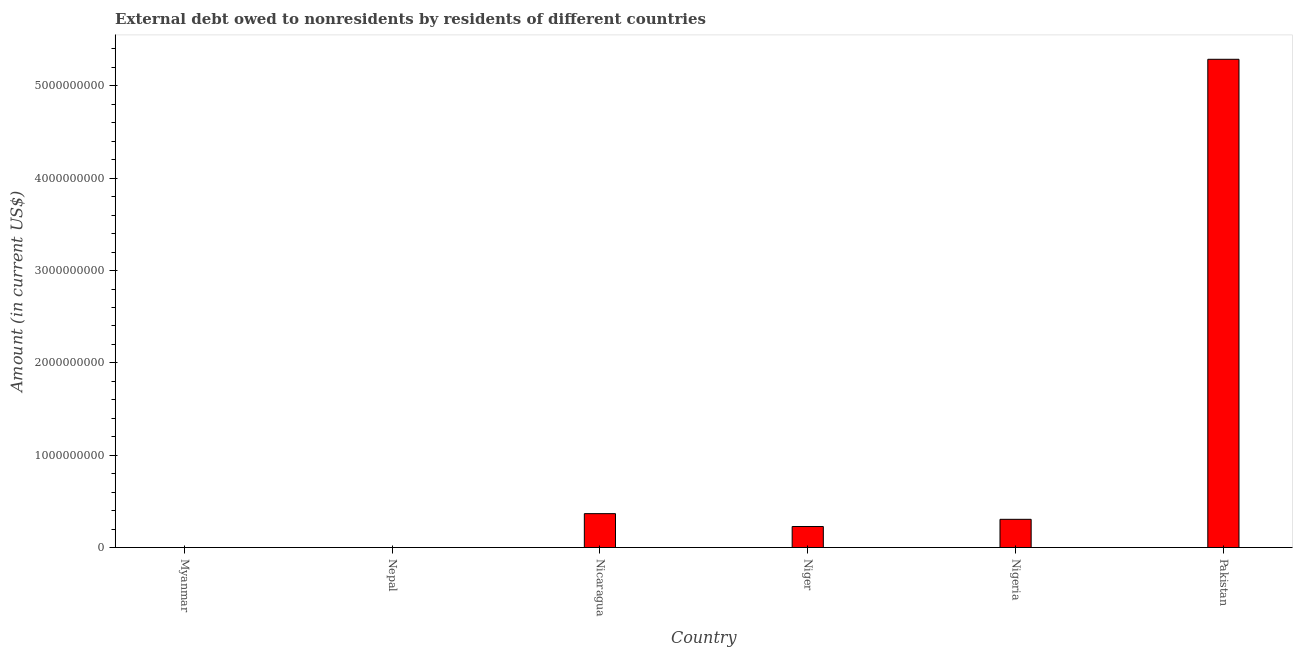Does the graph contain any zero values?
Keep it short and to the point. Yes. Does the graph contain grids?
Ensure brevity in your answer.  No. What is the title of the graph?
Your response must be concise. External debt owed to nonresidents by residents of different countries. What is the label or title of the Y-axis?
Your response must be concise. Amount (in current US$). What is the debt in Nicaragua?
Offer a terse response. 3.67e+08. Across all countries, what is the maximum debt?
Provide a short and direct response. 5.29e+09. In which country was the debt maximum?
Your response must be concise. Pakistan. What is the sum of the debt?
Provide a succinct answer. 6.19e+09. What is the difference between the debt in Niger and Pakistan?
Offer a terse response. -5.06e+09. What is the average debt per country?
Provide a succinct answer. 1.03e+09. What is the median debt?
Offer a very short reply. 2.66e+08. What is the ratio of the debt in Niger to that in Nigeria?
Provide a short and direct response. 0.74. Is the difference between the debt in Nigeria and Pakistan greater than the difference between any two countries?
Your response must be concise. No. What is the difference between the highest and the second highest debt?
Ensure brevity in your answer.  4.92e+09. What is the difference between the highest and the lowest debt?
Your answer should be very brief. 5.29e+09. What is the difference between two consecutive major ticks on the Y-axis?
Your answer should be very brief. 1.00e+09. Are the values on the major ticks of Y-axis written in scientific E-notation?
Offer a terse response. No. What is the Amount (in current US$) in Nepal?
Your answer should be compact. 0. What is the Amount (in current US$) in Nicaragua?
Your response must be concise. 3.67e+08. What is the Amount (in current US$) of Niger?
Make the answer very short. 2.27e+08. What is the Amount (in current US$) in Nigeria?
Make the answer very short. 3.05e+08. What is the Amount (in current US$) of Pakistan?
Your answer should be very brief. 5.29e+09. What is the difference between the Amount (in current US$) in Nicaragua and Niger?
Keep it short and to the point. 1.39e+08. What is the difference between the Amount (in current US$) in Nicaragua and Nigeria?
Keep it short and to the point. 6.15e+07. What is the difference between the Amount (in current US$) in Nicaragua and Pakistan?
Your answer should be very brief. -4.92e+09. What is the difference between the Amount (in current US$) in Niger and Nigeria?
Make the answer very short. -7.80e+07. What is the difference between the Amount (in current US$) in Niger and Pakistan?
Offer a terse response. -5.06e+09. What is the difference between the Amount (in current US$) in Nigeria and Pakistan?
Ensure brevity in your answer.  -4.98e+09. What is the ratio of the Amount (in current US$) in Nicaragua to that in Niger?
Your response must be concise. 1.61. What is the ratio of the Amount (in current US$) in Nicaragua to that in Nigeria?
Make the answer very short. 1.2. What is the ratio of the Amount (in current US$) in Nicaragua to that in Pakistan?
Keep it short and to the point. 0.07. What is the ratio of the Amount (in current US$) in Niger to that in Nigeria?
Your answer should be compact. 0.74. What is the ratio of the Amount (in current US$) in Niger to that in Pakistan?
Your answer should be compact. 0.04. What is the ratio of the Amount (in current US$) in Nigeria to that in Pakistan?
Keep it short and to the point. 0.06. 